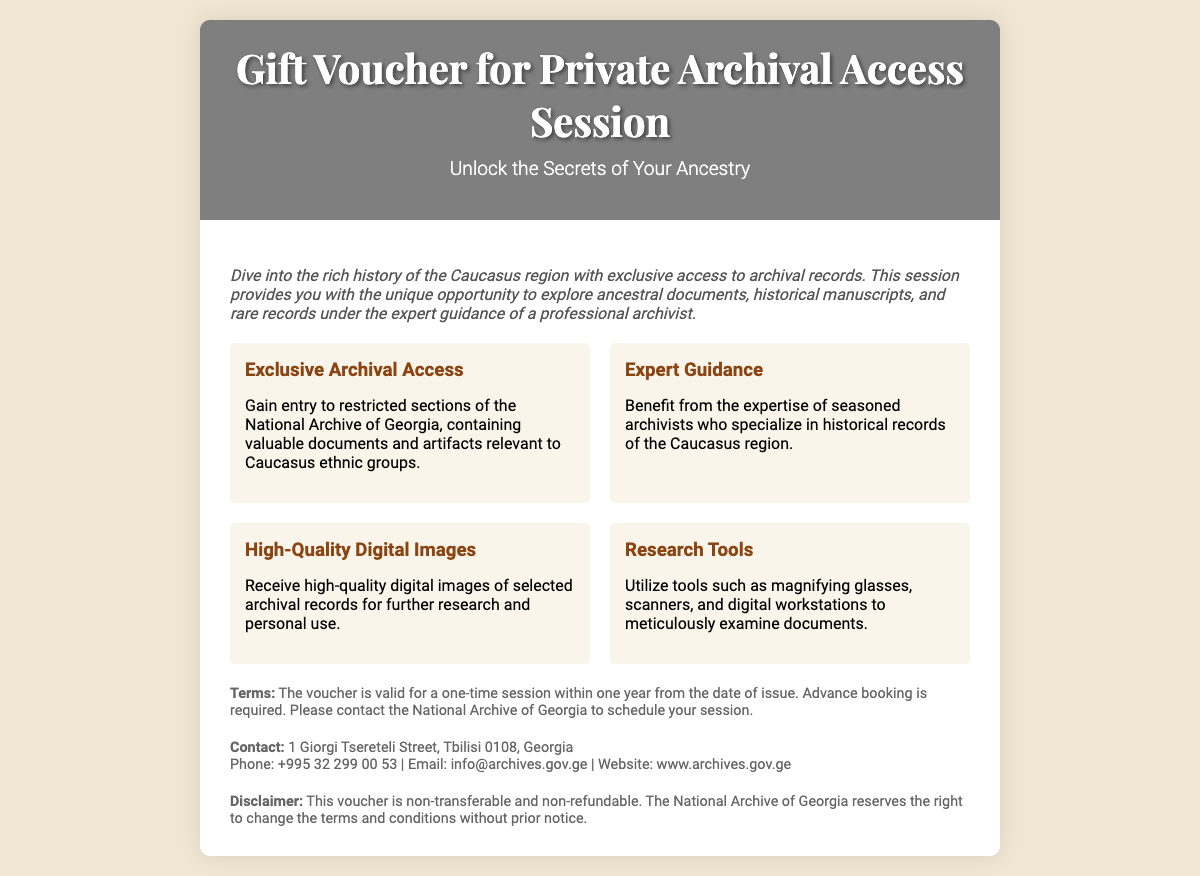what type of session does the voucher provide access to? The voucher grants access to a private archival access session at the National Archive of Georgia.
Answer: private archival access session who is the voucher intended for? The voucher is intended for individuals interested in exploring their ancestry and historical records.
Answer: individuals interested in ancestry which ethnic groups' documents are included in the archival access? The voucher emphasizes access to records relevant to Caucasus ethnic groups.
Answer: Caucasus ethnic groups what is required for booking the session? Advance booking is necessary to schedule the session.
Answer: Advance booking what is the validity period of the voucher? The voucher is valid for one-time access within one year from the date of issue.
Answer: one year what type of digital products will be received? The recipient will receive high-quality digital images of selected archival records.
Answer: high-quality digital images who can benefit from the expert guidance provided? The expertise of seasoned archivists should benefit individuals utilizing the voucher.
Answer: individuals utilizing the voucher where is the National Archive of Georgia located? The address of the National Archive of Georgia is specified in the document.
Answer: 1 Giorgi Tsereteli Street, Tbilisi 0108, Georgia what does the magnifying glass represent in the document? The magnifying glass symbolizes the tools available for examining documents during the archival session.
Answer: tools for examining documents 